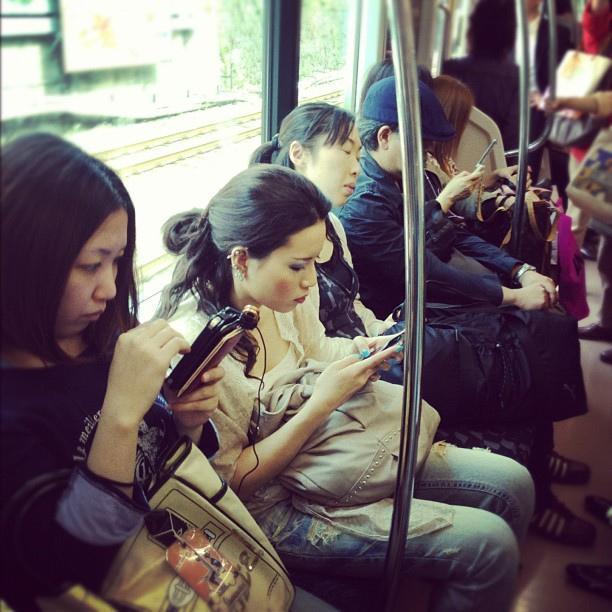If one was standing what would assist in maintaining their balance?
Pick the right solution, then justify: 'Answer: answer
Rationale: rationale.'
Options: Chair, phone, window, pole. Answer: pole.
Rationale: The metal pole is attached to the floor and ceiling for stability. 